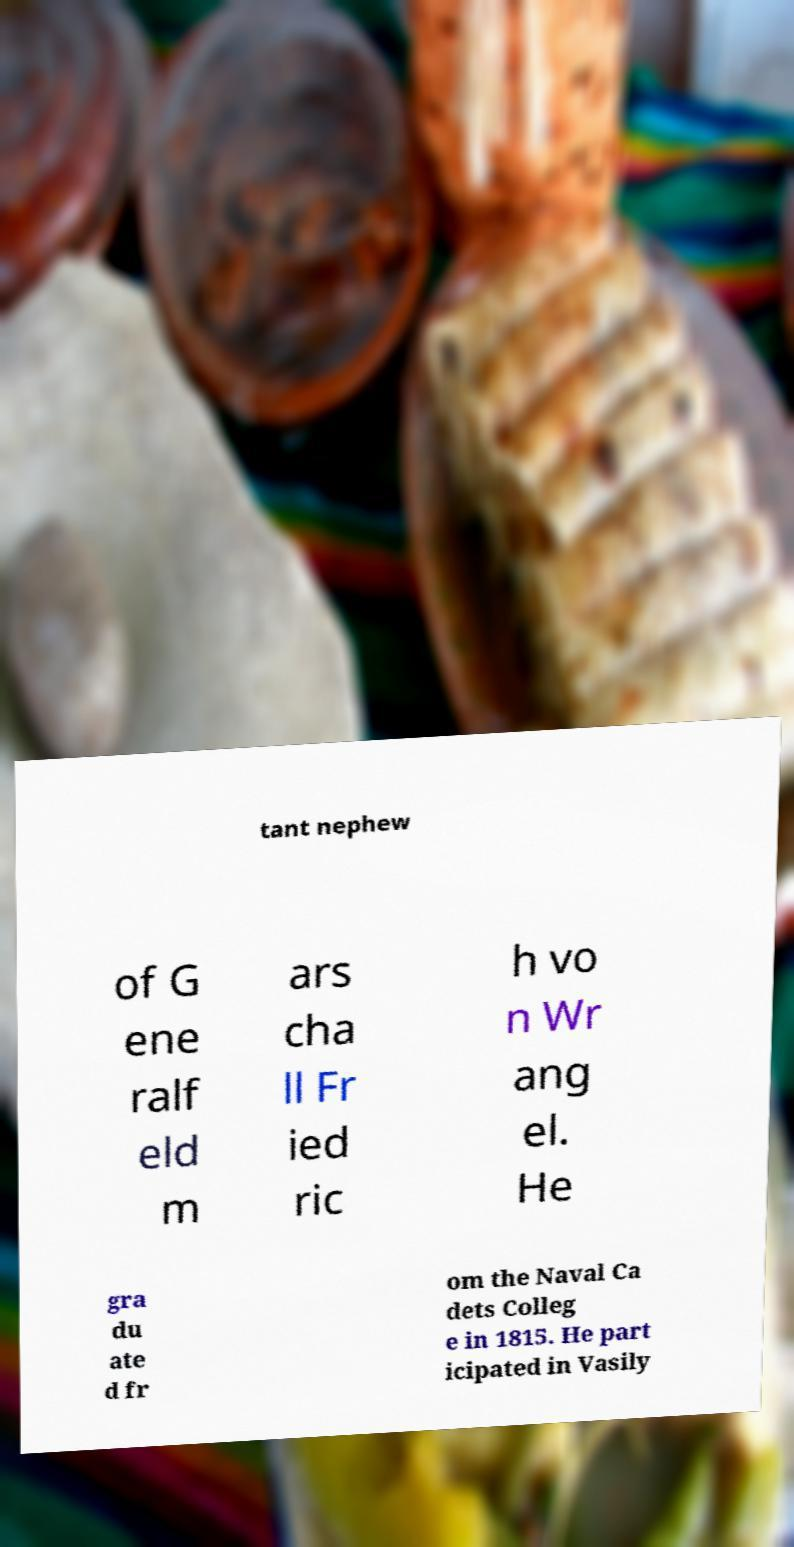I need the written content from this picture converted into text. Can you do that? tant nephew of G ene ralf eld m ars cha ll Fr ied ric h vo n Wr ang el. He gra du ate d fr om the Naval Ca dets Colleg e in 1815. He part icipated in Vasily 